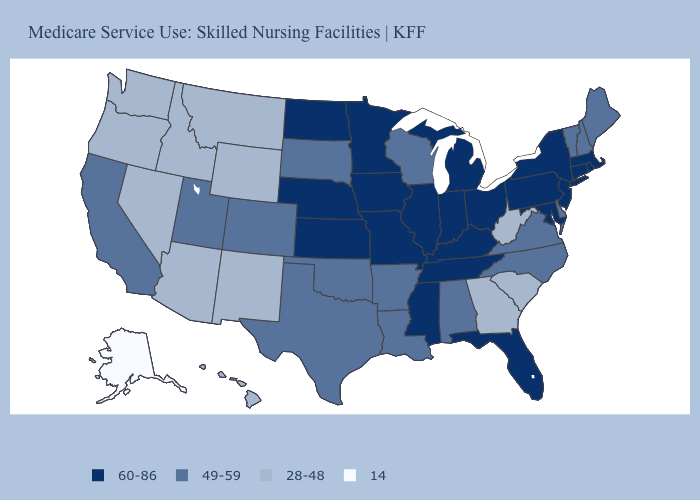Name the states that have a value in the range 49-59?
Be succinct. Alabama, Arkansas, California, Colorado, Delaware, Louisiana, Maine, New Hampshire, North Carolina, Oklahoma, South Dakota, Texas, Utah, Vermont, Virginia, Wisconsin. Does Colorado have the highest value in the West?
Keep it brief. Yes. Name the states that have a value in the range 49-59?
Short answer required. Alabama, Arkansas, California, Colorado, Delaware, Louisiana, Maine, New Hampshire, North Carolina, Oklahoma, South Dakota, Texas, Utah, Vermont, Virginia, Wisconsin. Does the first symbol in the legend represent the smallest category?
Short answer required. No. Name the states that have a value in the range 14?
Write a very short answer. Alaska. What is the value of California?
Answer briefly. 49-59. What is the value of Vermont?
Concise answer only. 49-59. Among the states that border Mississippi , does Tennessee have the lowest value?
Answer briefly. No. Does Rhode Island have the same value as Virginia?
Answer briefly. No. Which states have the lowest value in the MidWest?
Keep it brief. South Dakota, Wisconsin. What is the value of Tennessee?
Write a very short answer. 60-86. What is the lowest value in states that border Pennsylvania?
Short answer required. 28-48. Does Nebraska have a higher value than Rhode Island?
Concise answer only. No. What is the value of Iowa?
Be succinct. 60-86. What is the value of Alabama?
Be succinct. 49-59. 